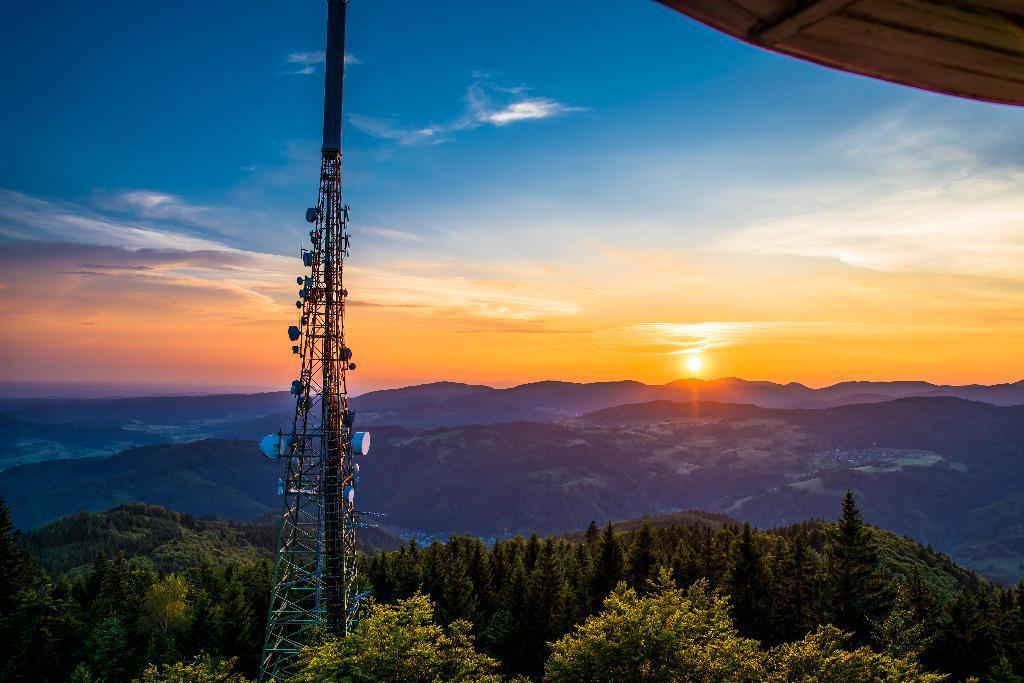How would you summarize this image in a sentence or two? At the bottom, we see the trees. In the middle, we see a tower. There are trees and the hills in the background. At the top, we see the sky and the clouds. We see the sun in the background. In the right top, we see an object in brown color. 